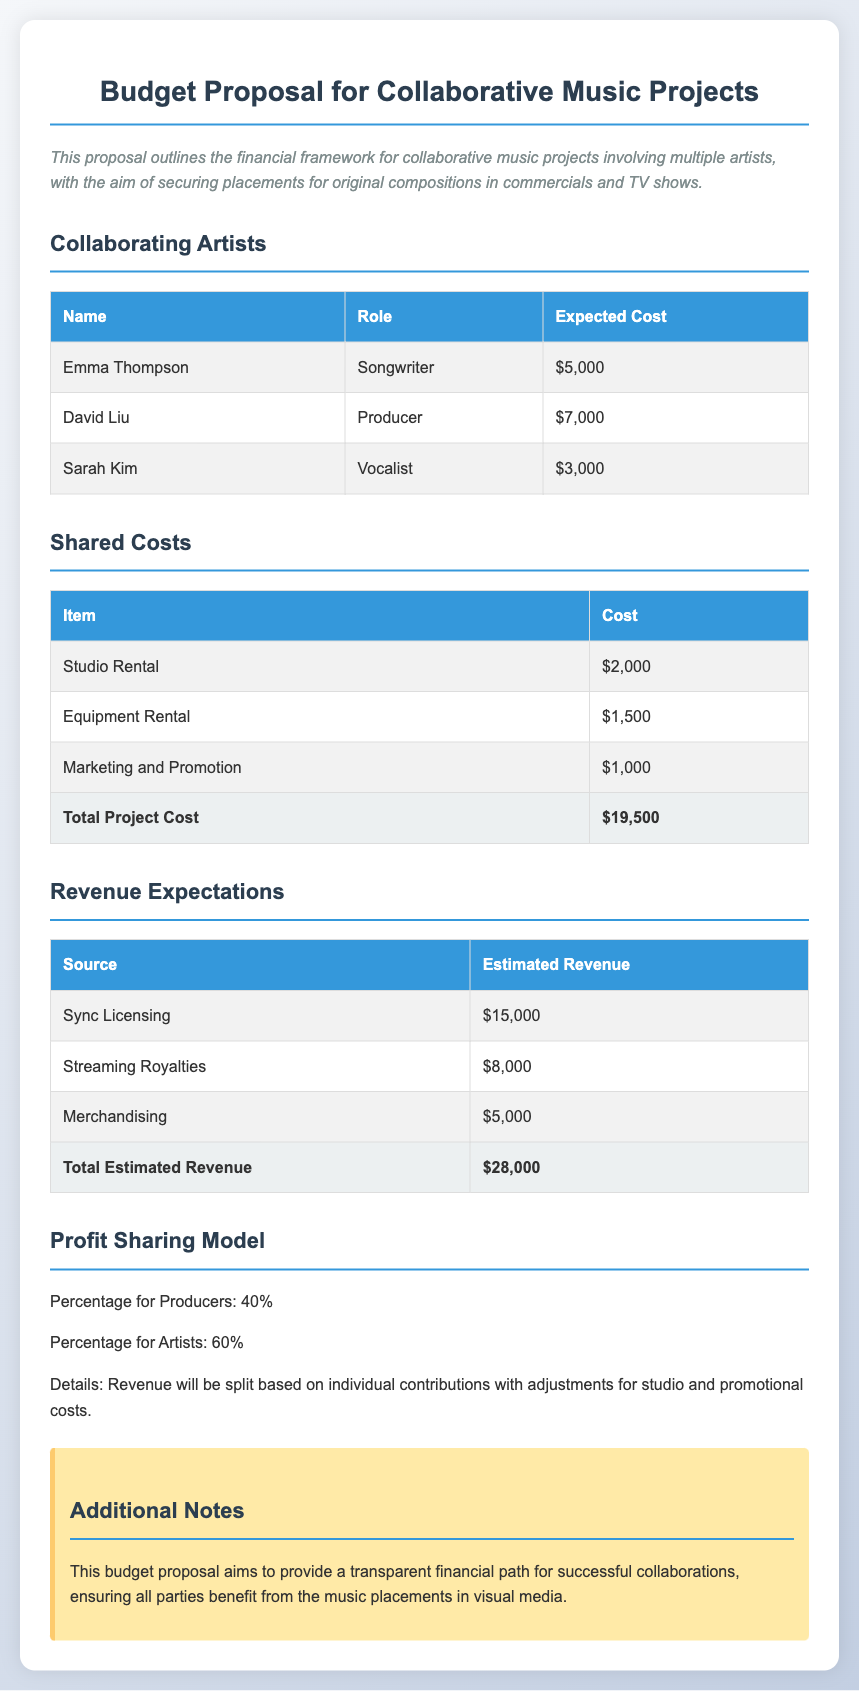What is the total expected cost for the collaborating artists? The total expected cost for the collaborating artists is found by adding up the individual costs: $5,000 + $7,000 + $3,000 = $15,000.
Answer: $15,000 What is the total project cost? The total project cost is listed as $19,500 in the shared costs section of the document.
Answer: $19,500 What percentage of revenue is allocated to artists? The document states that 60% of the revenue is allocated to artists in the profit sharing model.
Answer: 60% What is the estimated revenue from sync licensing? The estimated revenue from sync licensing is $15,000 as indicated in the revenue expectations section.
Answer: $15,000 Who is the producer among the collaborating artists? The document lists David Liu as the producer in the collaborating artists table.
Answer: David Liu What is the estimated total revenue? The estimated total revenue is found by summing all the revenue sources: $15,000 + $8,000 + $5,000 = $28,000.
Answer: $28,000 What is the cost for studio rental? The cost for studio rental is specified as $2,000 in the shared costs section.
Answer: $2,000 What item has the lowest cost in shared costs? The item with the lowest cost in the shared costs table is marketing and promotion for $1,000.
Answer: Marketing and Promotion What is the total revenue percentage split for producers? The document indicates that the total revenue percentage split for producers is 40%.
Answer: 40% 